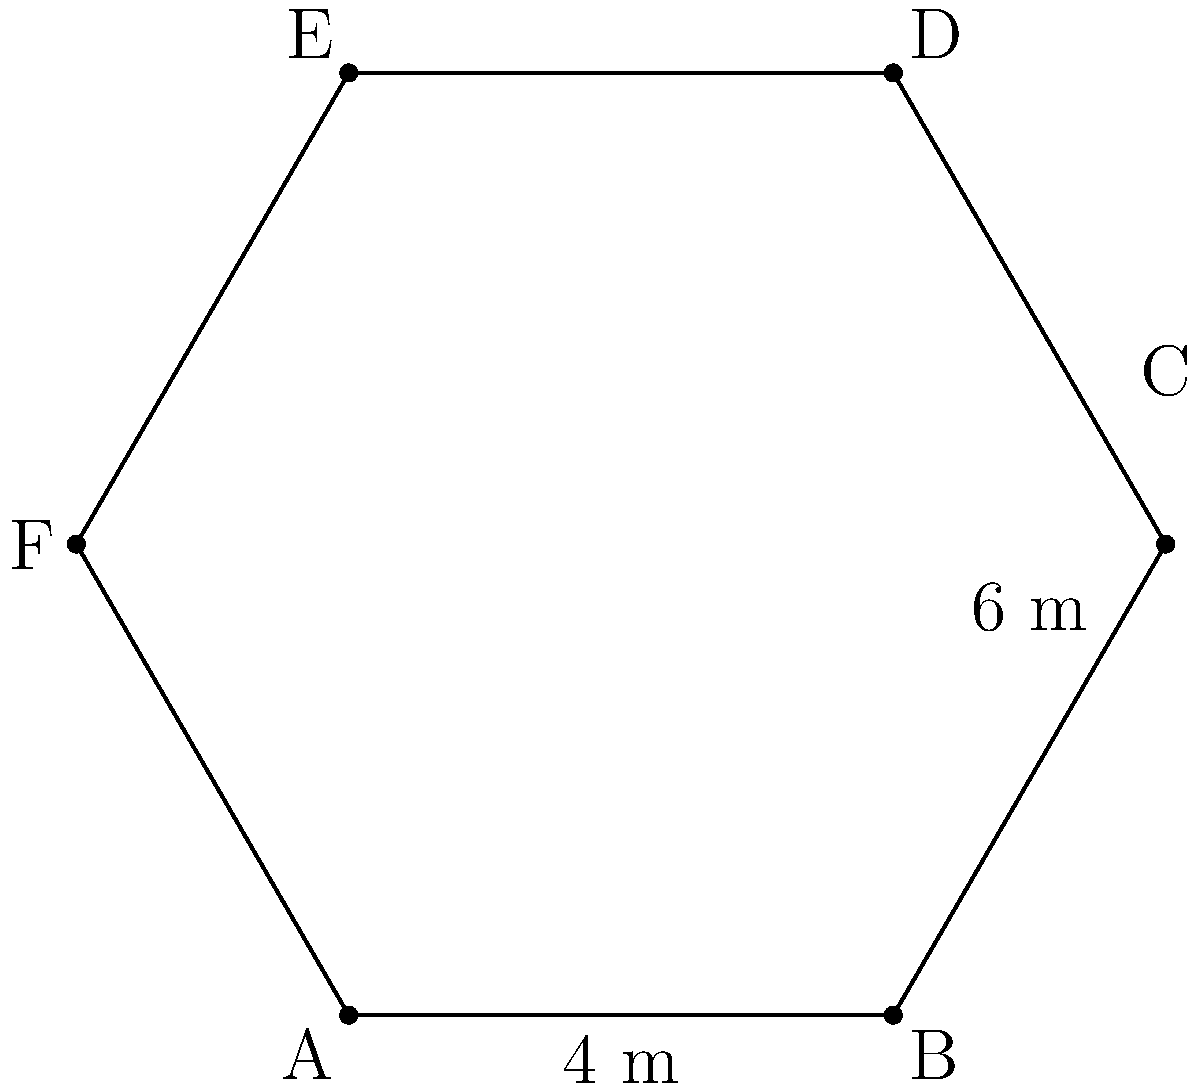As a choir director planning a new performance space, you're considering a hexagonal auditorium floor plan for optimal acoustics. The hexagon has two sides measuring 4 meters each and four sides measuring 6 meters each, as shown in the diagram. What is the total area of this hexagonal auditorium floor in square meters? To find the area of this irregular hexagon, we can divide it into six equilateral triangles and calculate their areas:

1. First, let's calculate the height (h) of one of the equilateral triangles with side length 6 m:
   $h = 6 \cdot \sin(60°) = 6 \cdot \frac{\sqrt{3}}{2} = 3\sqrt{3}$ m

2. The area of one equilateral triangle with side 6 m is:
   $A_1 = \frac{1}{2} \cdot 6 \cdot 3\sqrt{3} = 9\sqrt{3}$ m²

3. For the triangles with base 4 m, we need to calculate their height:
   $h_2 = 4 \cdot \tan(60°) = 4 \cdot \sqrt{3} = 4\sqrt{3}$ m

4. The area of one triangle with base 4 m is:
   $A_2 = \frac{1}{2} \cdot 4 \cdot 4\sqrt{3} = 8\sqrt{3}$ m²

5. The total area is the sum of four triangles with side 6 m and two triangles with base 4 m:
   $A_{total} = 4 \cdot 9\sqrt{3} + 2 \cdot 8\sqrt{3} = 52\sqrt{3}$ m²

6. Simplifying:
   $A_{total} = 52\sqrt{3} \approx 90.07$ m²
Answer: $52\sqrt{3}$ m² or approximately 90.07 m² 